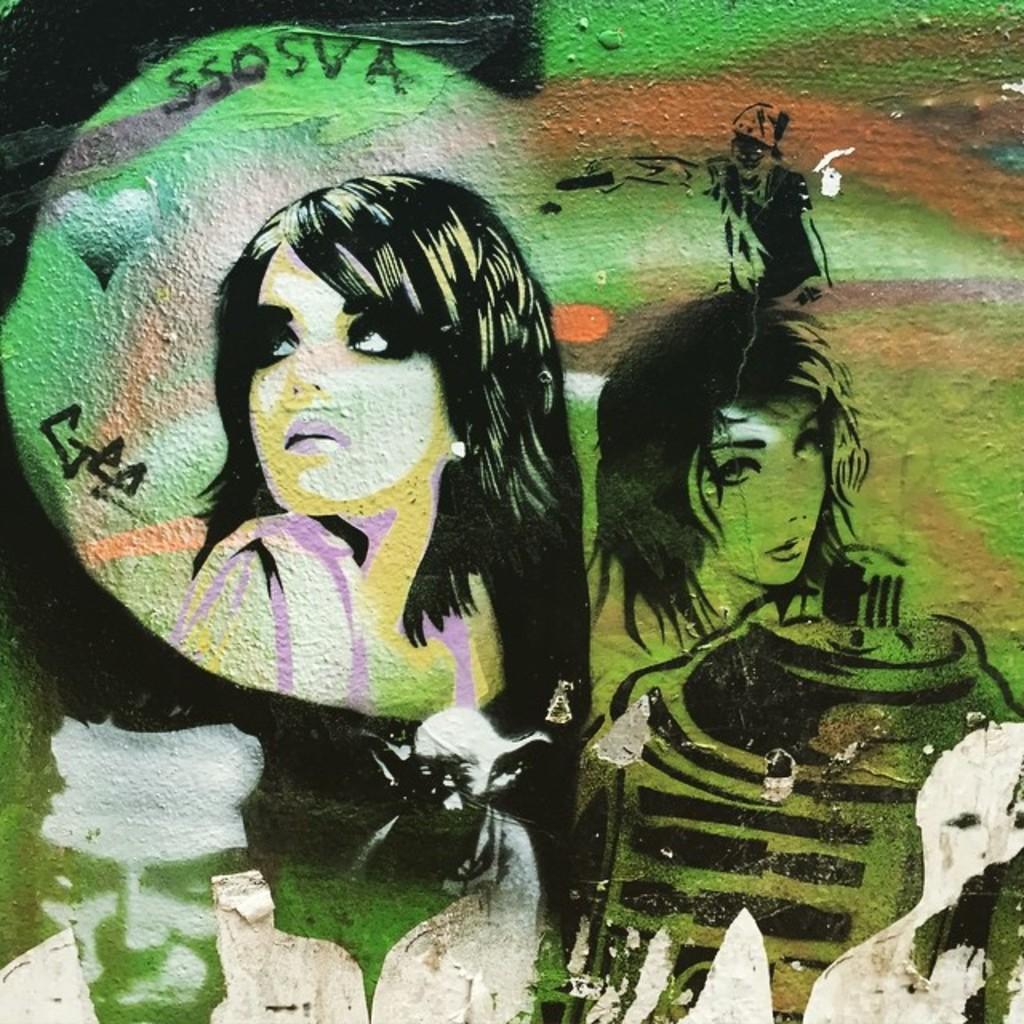How would you summarize this image in a sentence or two? In this image I can see the wall and on the wall I can see the painting of few persons which is green, black and white in color. 